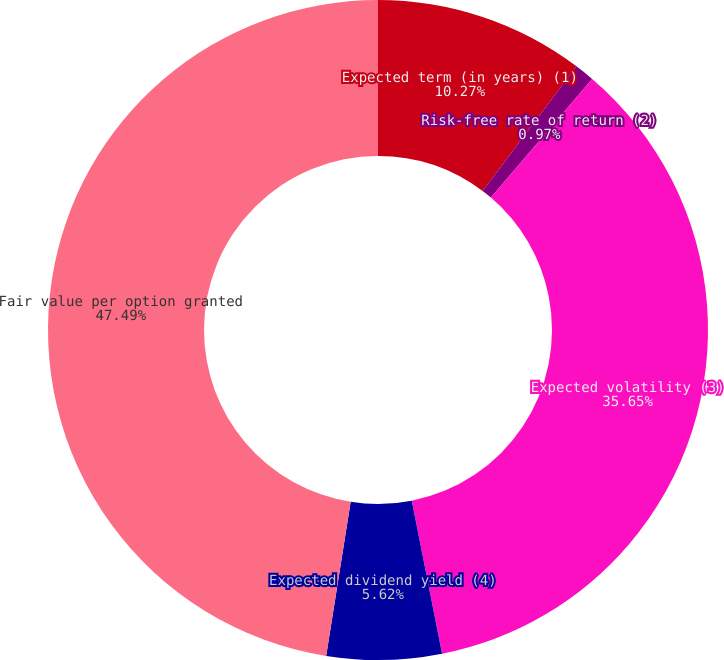Convert chart. <chart><loc_0><loc_0><loc_500><loc_500><pie_chart><fcel>Expected term (in years) (1)<fcel>Risk-free rate of return (2)<fcel>Expected volatility (3)<fcel>Expected dividend yield (4)<fcel>Fair value per option granted<nl><fcel>10.27%<fcel>0.97%<fcel>35.65%<fcel>5.62%<fcel>47.49%<nl></chart> 